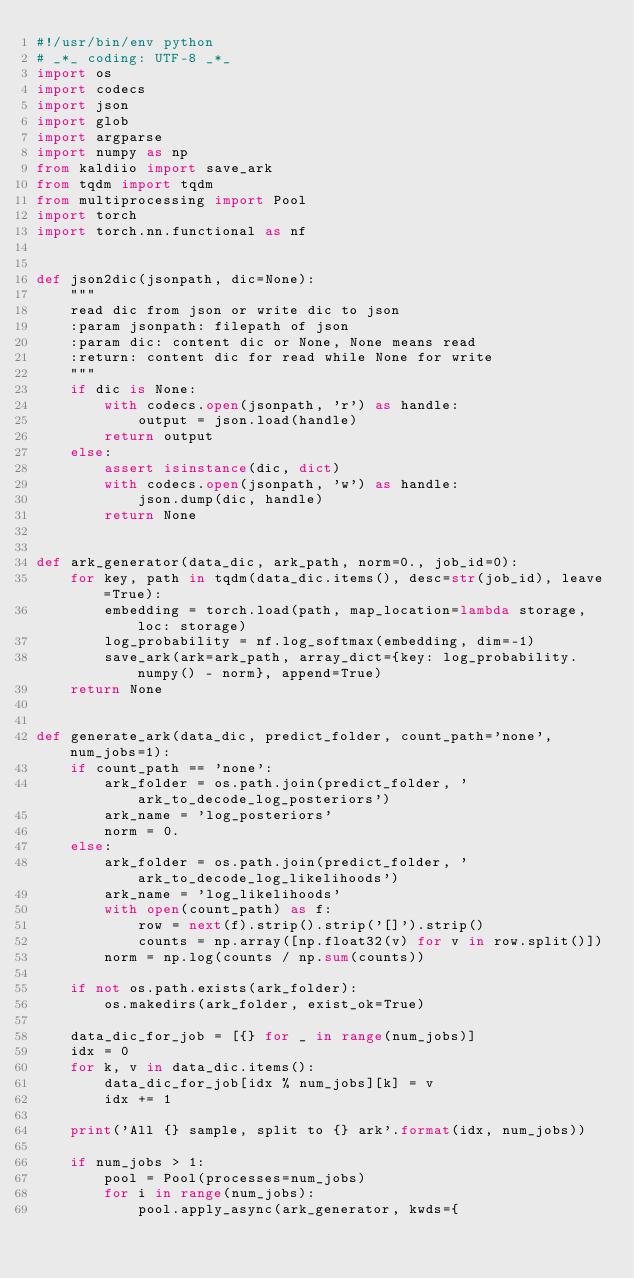<code> <loc_0><loc_0><loc_500><loc_500><_Python_>#!/usr/bin/env python
# _*_ coding: UTF-8 _*_
import os
import codecs
import json
import glob
import argparse
import numpy as np
from kaldiio import save_ark
from tqdm import tqdm
from multiprocessing import Pool
import torch
import torch.nn.functional as nf


def json2dic(jsonpath, dic=None):
    """
    read dic from json or write dic to json
    :param jsonpath: filepath of json
    :param dic: content dic or None, None means read
    :return: content dic for read while None for write
    """
    if dic is None:
        with codecs.open(jsonpath, 'r') as handle:
            output = json.load(handle)
        return output
    else:
        assert isinstance(dic, dict)
        with codecs.open(jsonpath, 'w') as handle:
            json.dump(dic, handle)
        return None


def ark_generator(data_dic, ark_path, norm=0., job_id=0):
    for key, path in tqdm(data_dic.items(), desc=str(job_id), leave=True):
        embedding = torch.load(path, map_location=lambda storage, loc: storage)
        log_probability = nf.log_softmax(embedding, dim=-1)
        save_ark(ark=ark_path, array_dict={key: log_probability.numpy() - norm}, append=True)
    return None


def generate_ark(data_dic, predict_folder, count_path='none', num_jobs=1):
    if count_path == 'none':
        ark_folder = os.path.join(predict_folder, 'ark_to_decode_log_posteriors')
        ark_name = 'log_posteriors'
        norm = 0.
    else:
        ark_folder = os.path.join(predict_folder, 'ark_to_decode_log_likelihoods')
        ark_name = 'log_likelihoods'
        with open(count_path) as f:
            row = next(f).strip().strip('[]').strip()
            counts = np.array([np.float32(v) for v in row.split()])
        norm = np.log(counts / np.sum(counts))

    if not os.path.exists(ark_folder):
        os.makedirs(ark_folder, exist_ok=True)

    data_dic_for_job = [{} for _ in range(num_jobs)]
    idx = 0
    for k, v in data_dic.items():
        data_dic_for_job[idx % num_jobs][k] = v
        idx += 1

    print('All {} sample, split to {} ark'.format(idx, num_jobs))

    if num_jobs > 1:
        pool = Pool(processes=num_jobs)
        for i in range(num_jobs):
            pool.apply_async(ark_generator, kwds={</code> 